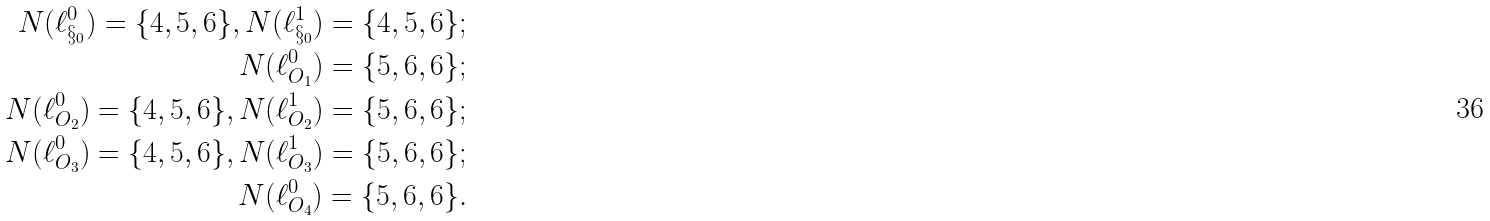<formula> <loc_0><loc_0><loc_500><loc_500>N ( \ell ^ { 0 } _ { \S _ { 0 } } ) = \{ 4 , 5 , 6 \} , N ( \ell ^ { 1 } _ { \S _ { 0 } } ) = \{ 4 , 5 , 6 \} ; \\ N ( \ell ^ { 0 } _ { O _ { 1 } } ) = \{ 5 , 6 , 6 \} ; \\ N ( \ell ^ { 0 } _ { O _ { 2 } } ) = \{ 4 , 5 , 6 \} , N ( \ell ^ { 1 } _ { O _ { 2 } } ) = \{ 5 , 6 , 6 \} ; \\ N ( \ell ^ { 0 } _ { O _ { 3 } } ) = \{ 4 , 5 , 6 \} , N ( \ell ^ { 1 } _ { O _ { 3 } } ) = \{ 5 , 6 , 6 \} ; \\ N ( \ell ^ { 0 } _ { O _ { 4 } } ) = \{ 5 , 6 , 6 \} . \\</formula> 